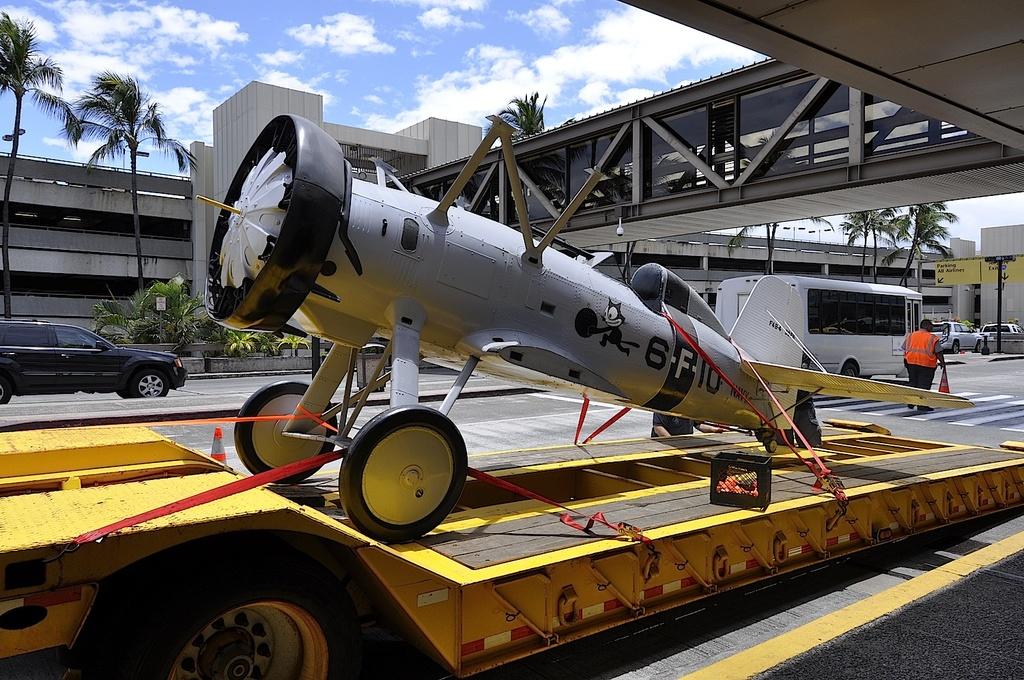What is the plane number?
Provide a succinct answer. 6-f10. 